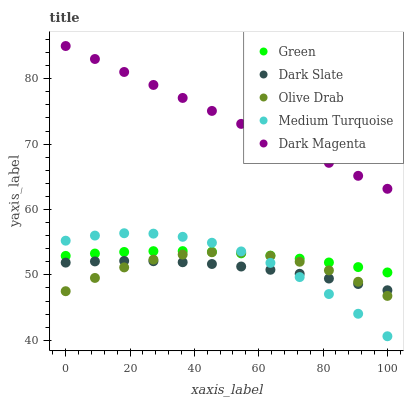Does Dark Slate have the minimum area under the curve?
Answer yes or no. Yes. Does Dark Magenta have the maximum area under the curve?
Answer yes or no. Yes. Does Green have the minimum area under the curve?
Answer yes or no. No. Does Green have the maximum area under the curve?
Answer yes or no. No. Is Dark Magenta the smoothest?
Answer yes or no. Yes. Is Medium Turquoise the roughest?
Answer yes or no. Yes. Is Green the smoothest?
Answer yes or no. No. Is Green the roughest?
Answer yes or no. No. Does Medium Turquoise have the lowest value?
Answer yes or no. Yes. Does Green have the lowest value?
Answer yes or no. No. Does Dark Magenta have the highest value?
Answer yes or no. Yes. Does Green have the highest value?
Answer yes or no. No. Is Medium Turquoise less than Dark Magenta?
Answer yes or no. Yes. Is Dark Magenta greater than Dark Slate?
Answer yes or no. Yes. Does Medium Turquoise intersect Green?
Answer yes or no. Yes. Is Medium Turquoise less than Green?
Answer yes or no. No. Is Medium Turquoise greater than Green?
Answer yes or no. No. Does Medium Turquoise intersect Dark Magenta?
Answer yes or no. No. 